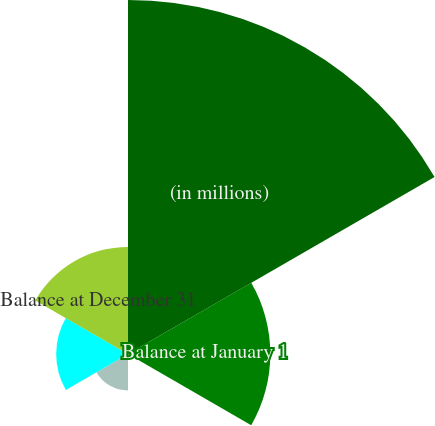Convert chart. <chart><loc_0><loc_0><loc_500><loc_500><pie_chart><fcel>(in millions)<fcel>Balance at January 1<fcel>Actual return on plan assets<fcel>Employer contributions<fcel>Benefits paid<fcel>Balance at December 31<nl><fcel>49.65%<fcel>19.96%<fcel>0.18%<fcel>5.12%<fcel>10.07%<fcel>15.02%<nl></chart> 